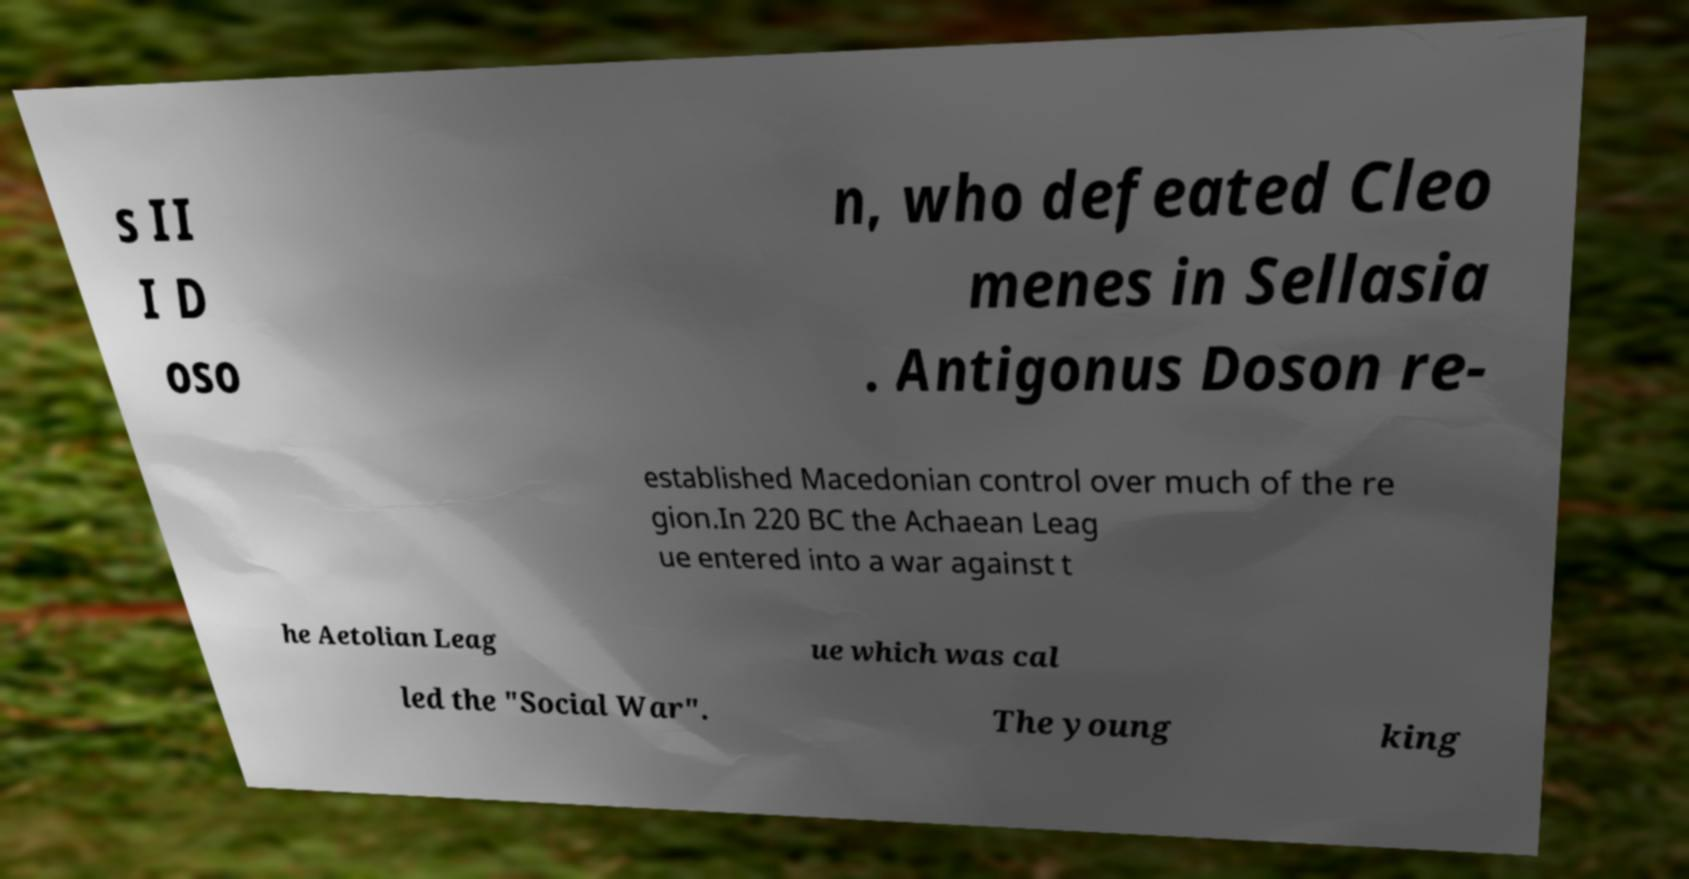I need the written content from this picture converted into text. Can you do that? s II I D oso n, who defeated Cleo menes in Sellasia . Antigonus Doson re- established Macedonian control over much of the re gion.In 220 BC the Achaean Leag ue entered into a war against t he Aetolian Leag ue which was cal led the "Social War". The young king 